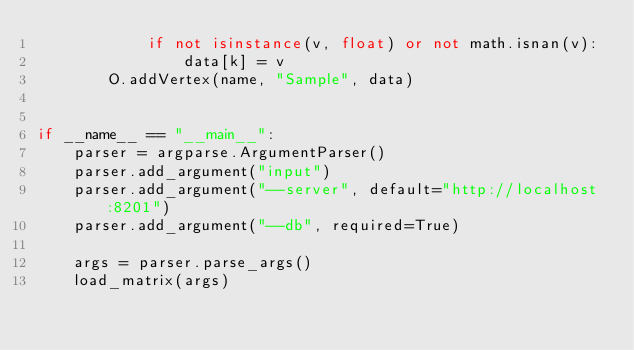Convert code to text. <code><loc_0><loc_0><loc_500><loc_500><_Python_>            if not isinstance(v, float) or not math.isnan(v):
                data[k] = v
        O.addVertex(name, "Sample", data)


if __name__ == "__main__":
    parser = argparse.ArgumentParser()
    parser.add_argument("input")
    parser.add_argument("--server", default="http://localhost:8201")
    parser.add_argument("--db", required=True)

    args = parser.parse_args()
    load_matrix(args)
</code> 